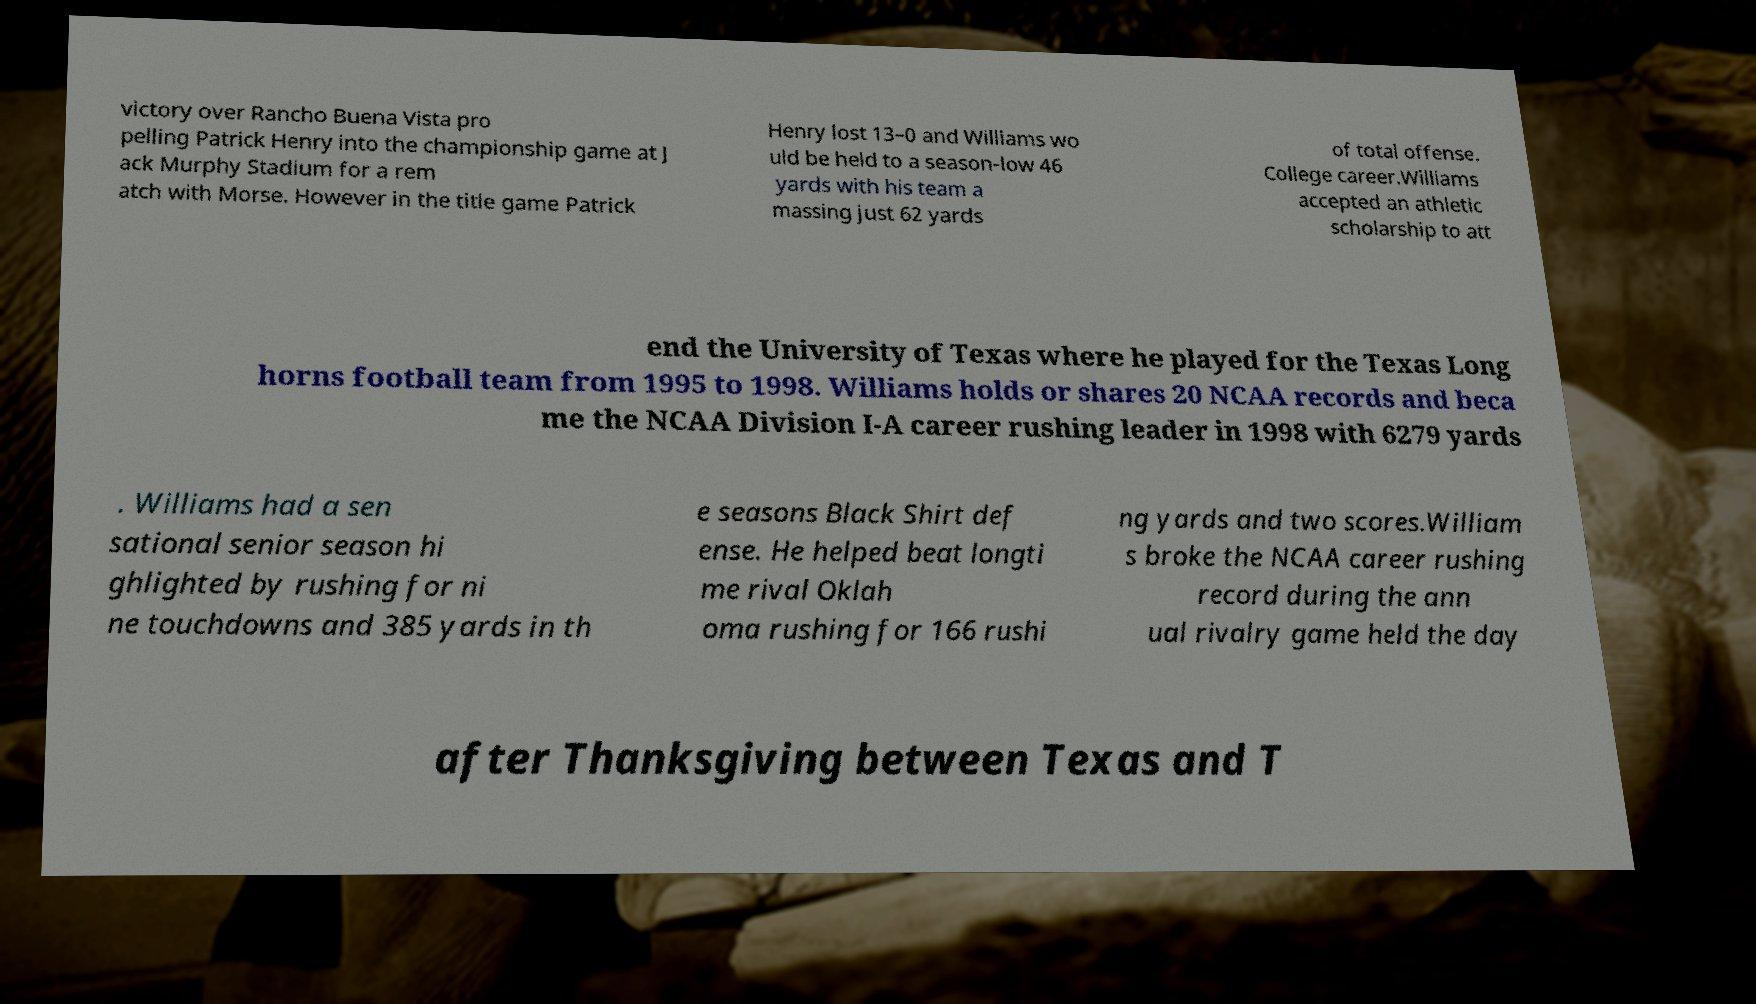What messages or text are displayed in this image? I need them in a readable, typed format. victory over Rancho Buena Vista pro pelling Patrick Henry into the championship game at J ack Murphy Stadium for a rem atch with Morse. However in the title game Patrick Henry lost 13–0 and Williams wo uld be held to a season-low 46 yards with his team a massing just 62 yards of total offense. College career.Williams accepted an athletic scholarship to att end the University of Texas where he played for the Texas Long horns football team from 1995 to 1998. Williams holds or shares 20 NCAA records and beca me the NCAA Division I-A career rushing leader in 1998 with 6279 yards . Williams had a sen sational senior season hi ghlighted by rushing for ni ne touchdowns and 385 yards in th e seasons Black Shirt def ense. He helped beat longti me rival Oklah oma rushing for 166 rushi ng yards and two scores.William s broke the NCAA career rushing record during the ann ual rivalry game held the day after Thanksgiving between Texas and T 